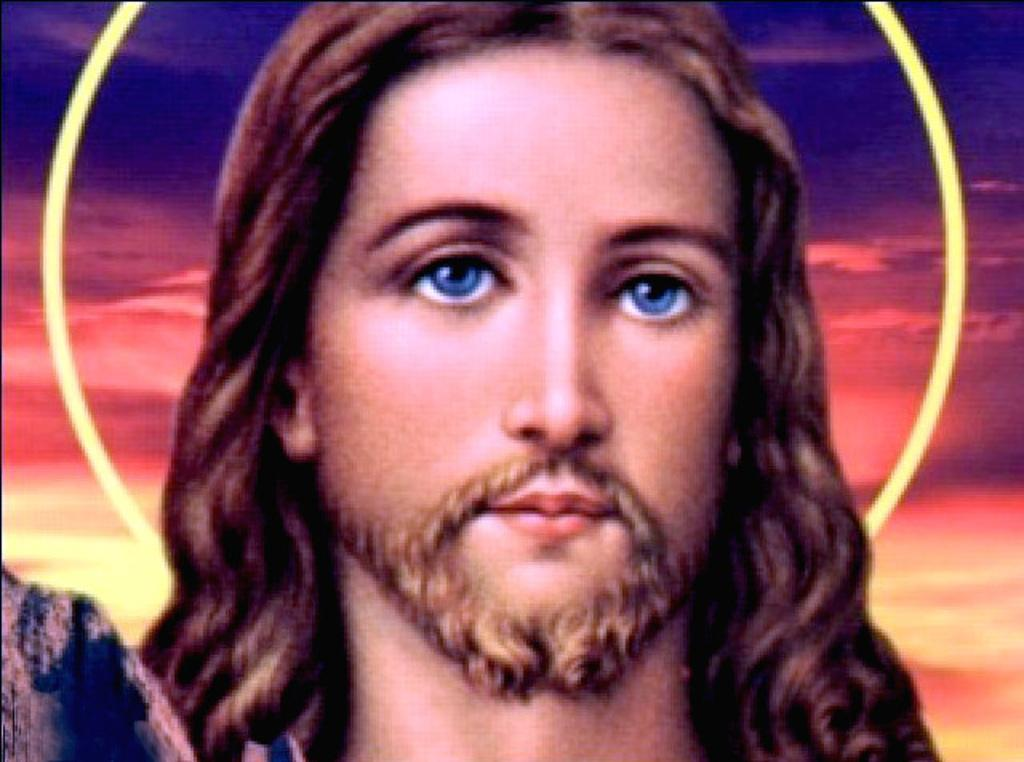What is the main subject of the image? There is a depiction of a person in the center of the image. How many clams are visible in the image? There are no clams present in the image. What type of burst can be seen in the image? There is no burst visible in the image. 